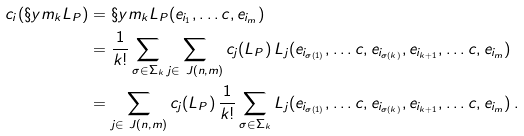<formula> <loc_0><loc_0><loc_500><loc_500>c _ { i } ( \S y m _ { k } L _ { P } ) & = \S y m _ { k } L _ { P } ( e _ { i _ { 1 } } , \dots c , e _ { i _ { m } } ) \\ & = \frac { 1 } { k ! } \sum _ { \sigma \in \Sigma _ { k } } \sum _ { j \in \ J ( n , m ) } c _ { j } ( L _ { P } ) \, L _ { j } ( e _ { i _ { \sigma ( 1 ) } } , \dots c , e _ { i _ { \sigma ( k ) } } , e _ { i _ { k + 1 } } , \dots c , e _ { i _ { m } } ) \\ & = \sum _ { j \in \ J ( n , m ) } c _ { j } ( L _ { P } ) \, \frac { 1 } { k ! } \sum _ { \sigma \in \Sigma _ { k } } L _ { j } ( e _ { i _ { \sigma ( 1 ) } } , \dots c , e _ { i _ { \sigma ( k ) } } , e _ { i _ { k + 1 } } , \dots c , e _ { i _ { m } } ) \, .</formula> 